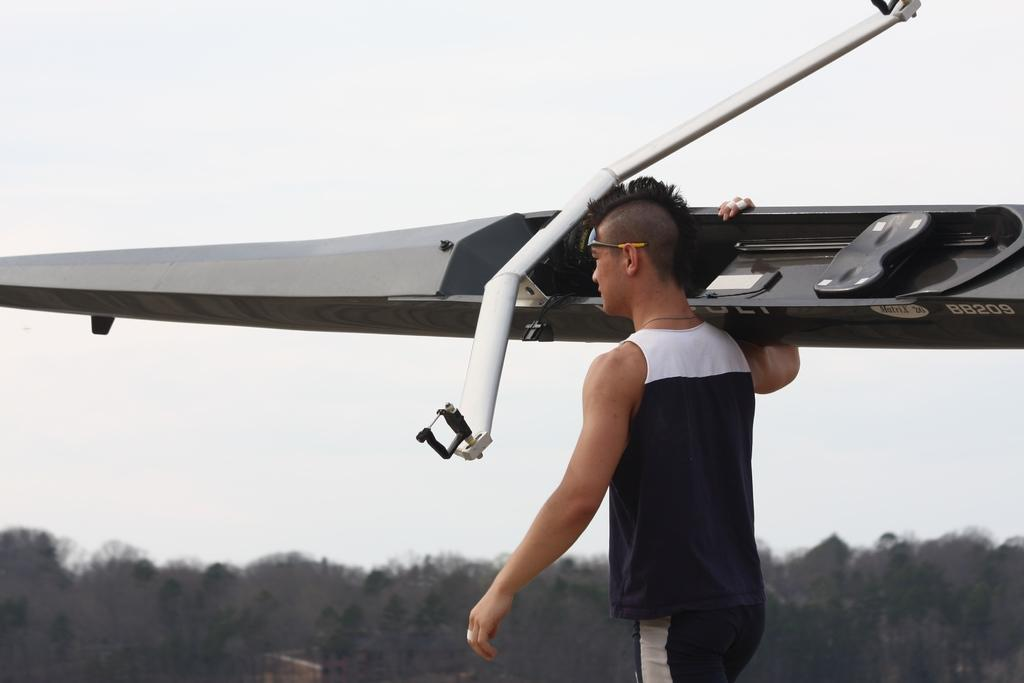<image>
Offer a succinct explanation of the picture presented. Man carrying a Kayak that says Matrix 26 BB209. 